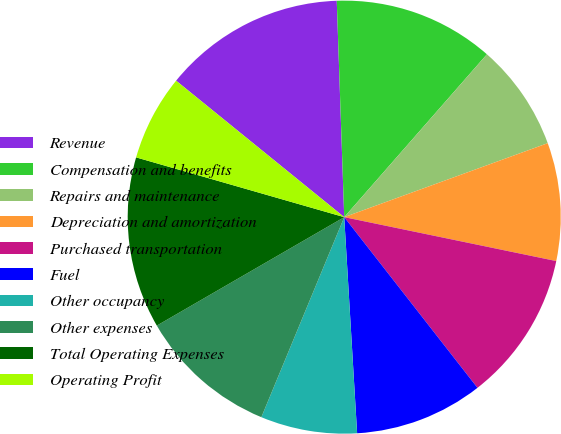<chart> <loc_0><loc_0><loc_500><loc_500><pie_chart><fcel>Revenue<fcel>Compensation and benefits<fcel>Repairs and maintenance<fcel>Depreciation and amortization<fcel>Purchased transportation<fcel>Fuel<fcel>Other occupancy<fcel>Other expenses<fcel>Total Operating Expenses<fcel>Operating Profit<nl><fcel>13.6%<fcel>12.0%<fcel>8.0%<fcel>8.8%<fcel>11.2%<fcel>9.6%<fcel>7.2%<fcel>10.4%<fcel>12.8%<fcel>6.4%<nl></chart> 